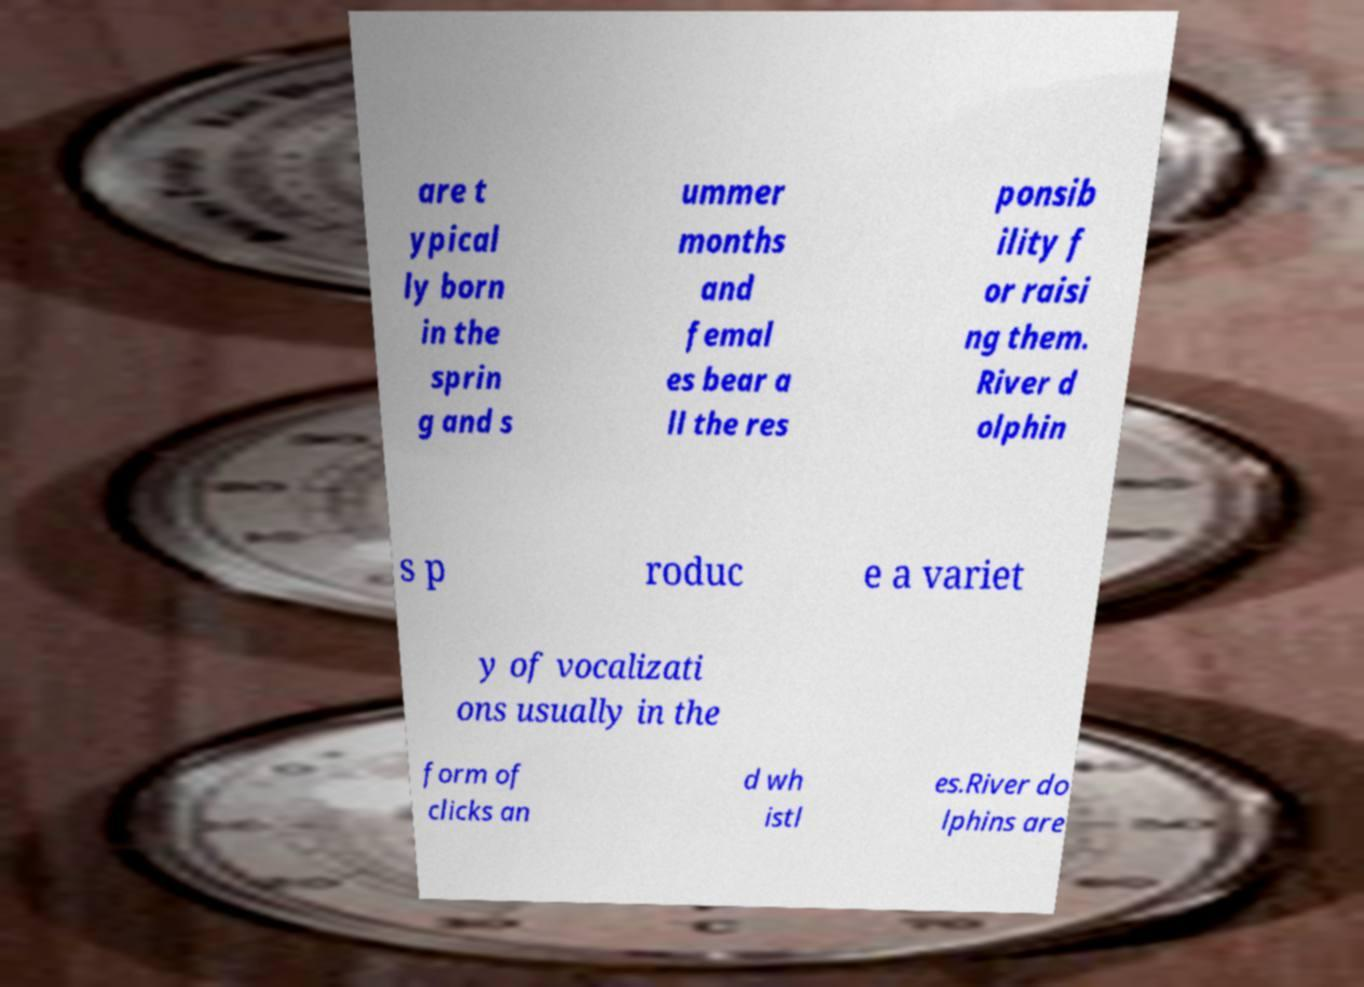Could you assist in decoding the text presented in this image and type it out clearly? are t ypical ly born in the sprin g and s ummer months and femal es bear a ll the res ponsib ility f or raisi ng them. River d olphin s p roduc e a variet y of vocalizati ons usually in the form of clicks an d wh istl es.River do lphins are 